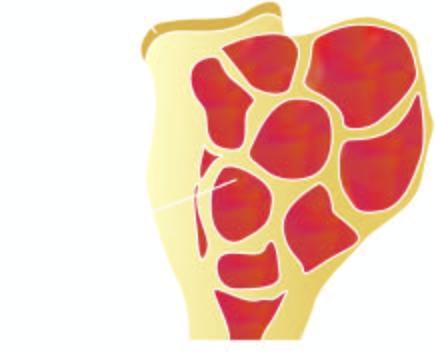does sectioned surface show circumscribed, dark tan, haemorrhagic and necrotic tumour?
Answer the question using a single word or phrase. Yes 